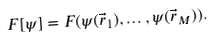Convert formula to latex. <formula><loc_0><loc_0><loc_500><loc_500>F [ \psi ] = F ( \psi ( \vec { r } _ { 1 } ) , \dots , \psi ( \vec { r } _ { M } ) ) .</formula> 